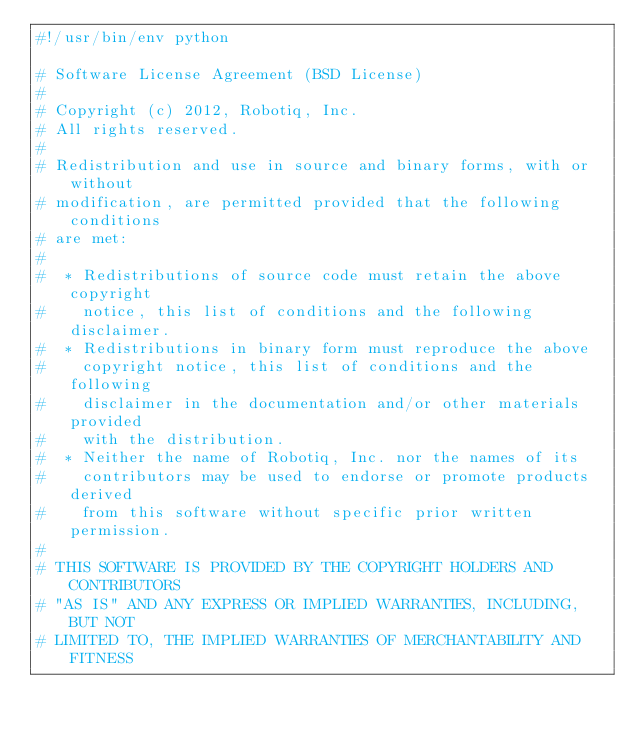Convert code to text. <code><loc_0><loc_0><loc_500><loc_500><_Python_>#!/usr/bin/env python

# Software License Agreement (BSD License)
#
# Copyright (c) 2012, Robotiq, Inc.
# All rights reserved.
#
# Redistribution and use in source and binary forms, with or without
# modification, are permitted provided that the following conditions
# are met:
#
#  * Redistributions of source code must retain the above copyright
#    notice, this list of conditions and the following disclaimer.
#  * Redistributions in binary form must reproduce the above
#    copyright notice, this list of conditions and the following
#    disclaimer in the documentation and/or other materials provided
#    with the distribution.
#  * Neither the name of Robotiq, Inc. nor the names of its
#    contributors may be used to endorse or promote products derived
#    from this software without specific prior written permission.
#
# THIS SOFTWARE IS PROVIDED BY THE COPYRIGHT HOLDERS AND CONTRIBUTORS
# "AS IS" AND ANY EXPRESS OR IMPLIED WARRANTIES, INCLUDING, BUT NOT
# LIMITED TO, THE IMPLIED WARRANTIES OF MERCHANTABILITY AND FITNESS</code> 